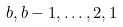Convert formula to latex. <formula><loc_0><loc_0><loc_500><loc_500>b , b - 1 , \dots , 2 , 1</formula> 